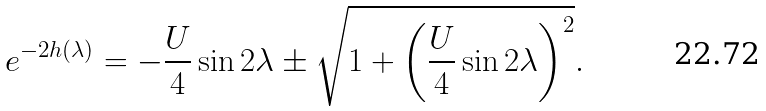Convert formula to latex. <formula><loc_0><loc_0><loc_500><loc_500>e ^ { - 2 h ( \lambda ) } = - \frac { U } { 4 } \sin 2 \lambda \pm \sqrt { 1 + \left ( \frac { U } { 4 } \sin 2 \lambda \right ) ^ { 2 } } .</formula> 